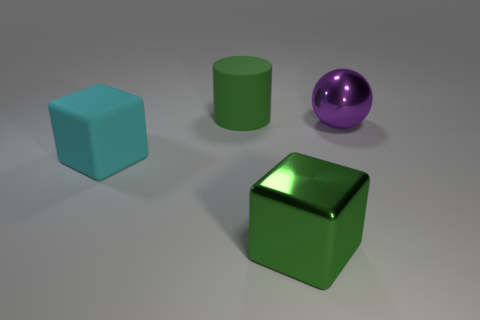Add 3 cyan things. How many objects exist? 7 Subtract all cylinders. How many objects are left? 3 Subtract all red balls. How many green blocks are left? 1 Add 2 small cyan matte balls. How many small cyan matte balls exist? 2 Subtract all cyan cubes. How many cubes are left? 1 Subtract 0 gray cylinders. How many objects are left? 4 Subtract all yellow blocks. Subtract all gray cylinders. How many blocks are left? 2 Subtract all yellow balls. Subtract all big green matte cylinders. How many objects are left? 3 Add 3 matte objects. How many matte objects are left? 5 